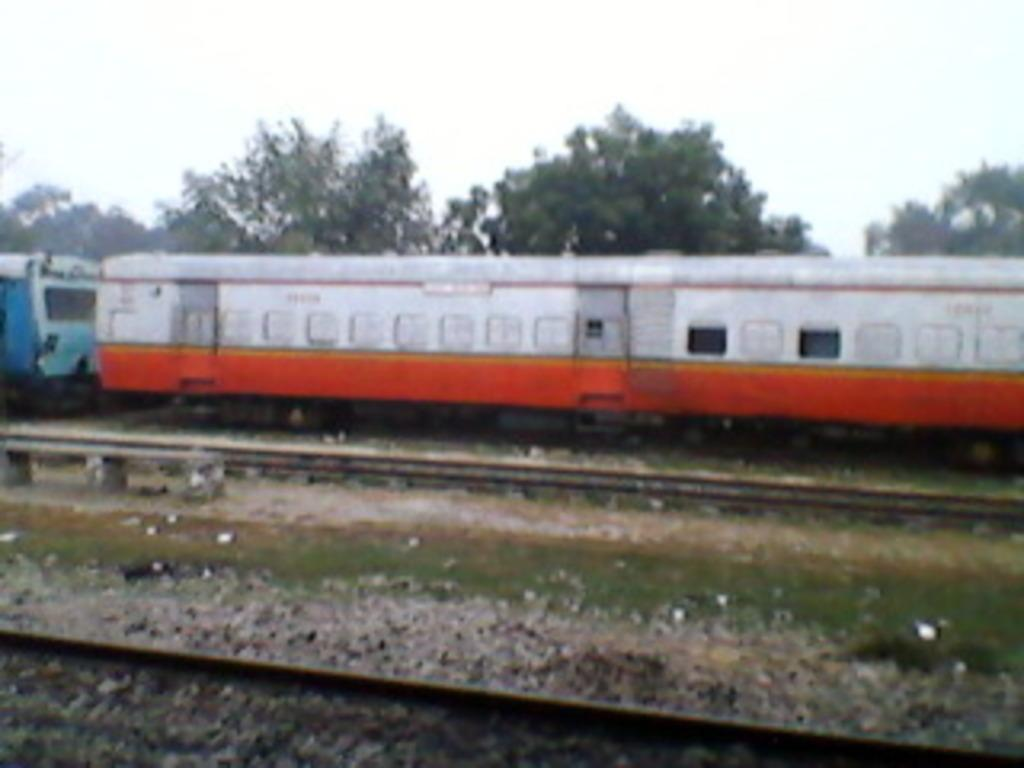What is located on the track in the image? There is a train on the track in the image. What type of vegetation is present near the track? The area around the track has grass. What can be seen in the background of the image? There are trees and the sky visible in the background of the image. What type of animal is providing the voiceover for the train in the image? There is no voiceover or animal present in the image; it is a static image of a train on a track. 